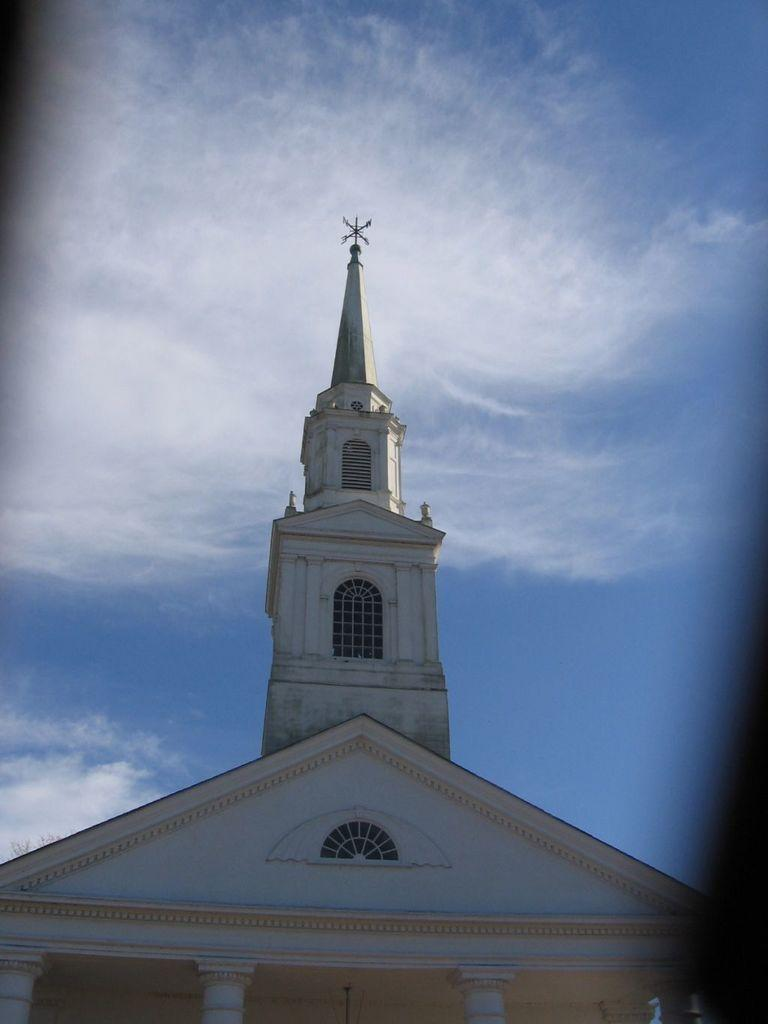What is the main subject of the image? There is a building in the image. What can be seen in the background of the image? There are clouds in the sky in the background of the image. Can you see any ghosts interacting with the building in the image? There are no ghosts present in the image. What type of answer can be seen written on the building in the image? There is no answer written on the building in the image. 